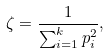Convert formula to latex. <formula><loc_0><loc_0><loc_500><loc_500>\zeta = \frac { 1 } { \sum _ { i = 1 } ^ { k } p _ { i } ^ { 2 } } ,</formula> 